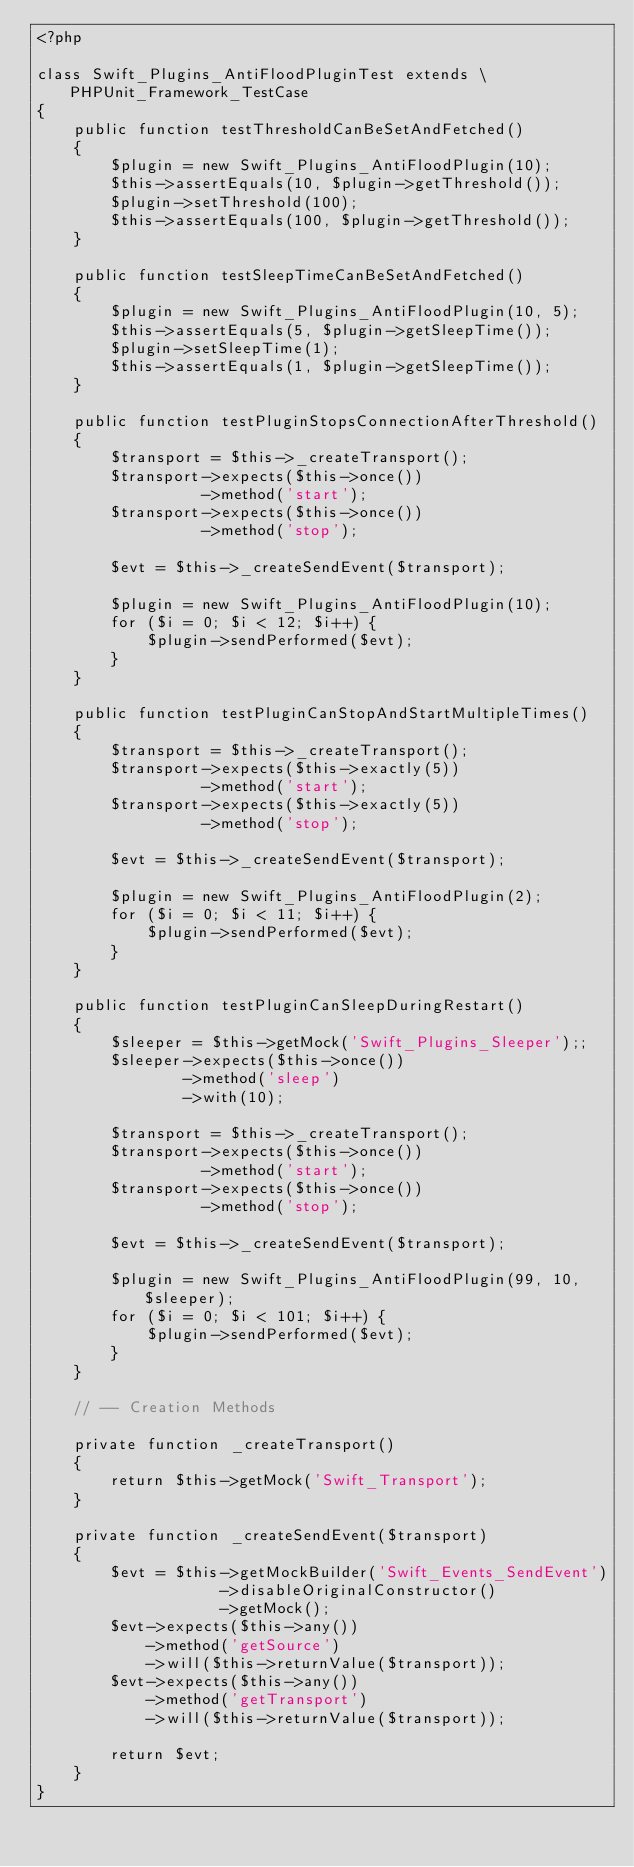Convert code to text. <code><loc_0><loc_0><loc_500><loc_500><_PHP_><?php

class Swift_Plugins_AntiFloodPluginTest extends \PHPUnit_Framework_TestCase
{
    public function testThresholdCanBeSetAndFetched()
    {
        $plugin = new Swift_Plugins_AntiFloodPlugin(10);
        $this->assertEquals(10, $plugin->getThreshold());
        $plugin->setThreshold(100);
        $this->assertEquals(100, $plugin->getThreshold());
    }

    public function testSleepTimeCanBeSetAndFetched()
    {
        $plugin = new Swift_Plugins_AntiFloodPlugin(10, 5);
        $this->assertEquals(5, $plugin->getSleepTime());
        $plugin->setSleepTime(1);
        $this->assertEquals(1, $plugin->getSleepTime());
    }

    public function testPluginStopsConnectionAfterThreshold()
    {
        $transport = $this->_createTransport();
        $transport->expects($this->once())
                  ->method('start');
        $transport->expects($this->once())
                  ->method('stop');

        $evt = $this->_createSendEvent($transport);

        $plugin = new Swift_Plugins_AntiFloodPlugin(10);
        for ($i = 0; $i < 12; $i++) {
            $plugin->sendPerformed($evt);
        }
    }

    public function testPluginCanStopAndStartMultipleTimes()
    {
        $transport = $this->_createTransport();
        $transport->expects($this->exactly(5))
                  ->method('start');
        $transport->expects($this->exactly(5))
                  ->method('stop');

        $evt = $this->_createSendEvent($transport);

        $plugin = new Swift_Plugins_AntiFloodPlugin(2);
        for ($i = 0; $i < 11; $i++) {
            $plugin->sendPerformed($evt);
        }
    }

    public function testPluginCanSleepDuringRestart()
    {
        $sleeper = $this->getMock('Swift_Plugins_Sleeper');;
        $sleeper->expects($this->once())
                ->method('sleep')
                ->with(10);

        $transport = $this->_createTransport();
        $transport->expects($this->once())
                  ->method('start');
        $transport->expects($this->once())
                  ->method('stop');

        $evt = $this->_createSendEvent($transport);

        $plugin = new Swift_Plugins_AntiFloodPlugin(99, 10, $sleeper);
        for ($i = 0; $i < 101; $i++) {
            $plugin->sendPerformed($evt);
        }
    }

    // -- Creation Methods

    private function _createTransport()
    {
        return $this->getMock('Swift_Transport');
    }

    private function _createSendEvent($transport)
    {
        $evt = $this->getMockBuilder('Swift_Events_SendEvent')
                    ->disableOriginalConstructor()
                    ->getMock();
        $evt->expects($this->any())
            ->method('getSource')
            ->will($this->returnValue($transport));
        $evt->expects($this->any())
            ->method('getTransport')
            ->will($this->returnValue($transport));

        return $evt;
    }
}
</code> 